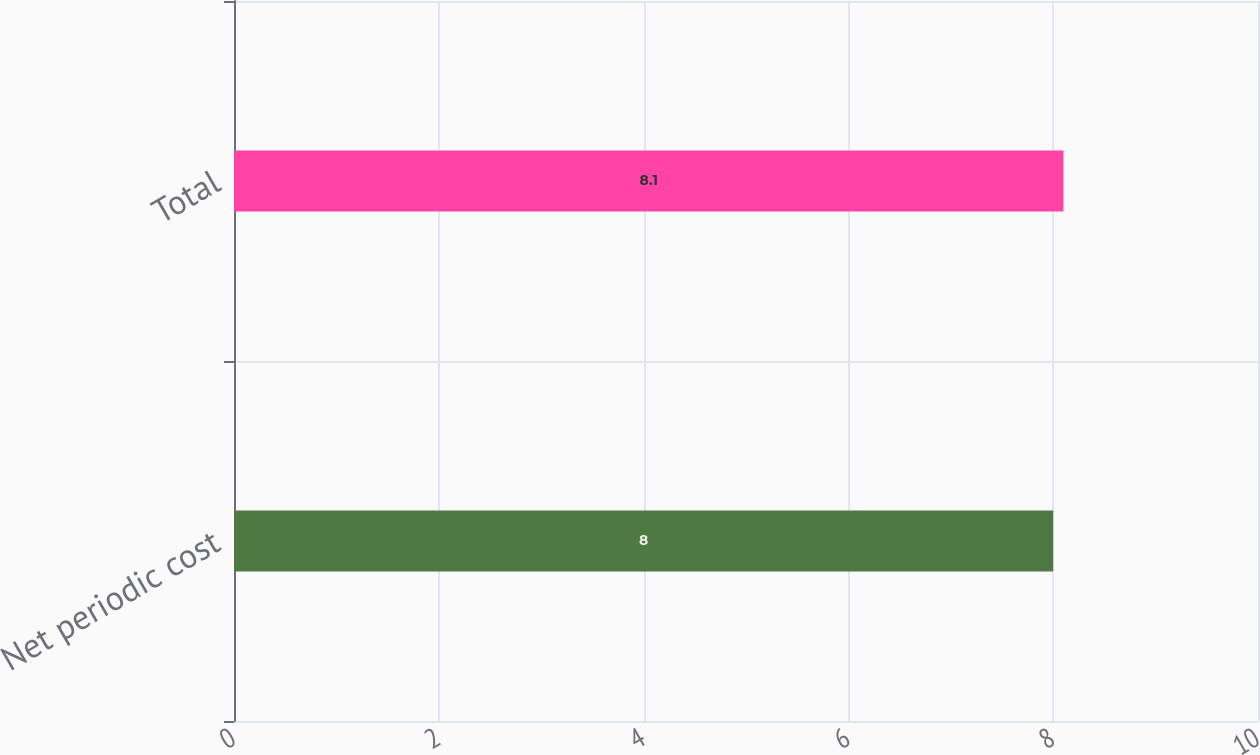Convert chart to OTSL. <chart><loc_0><loc_0><loc_500><loc_500><bar_chart><fcel>Net periodic cost<fcel>Total<nl><fcel>8<fcel>8.1<nl></chart> 